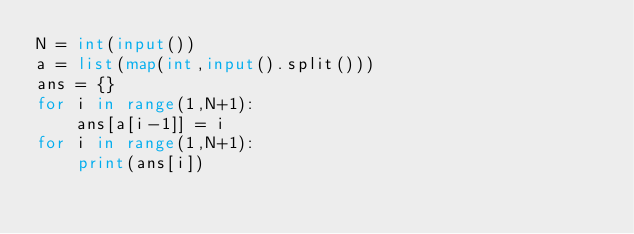Convert code to text. <code><loc_0><loc_0><loc_500><loc_500><_Python_>N = int(input())
a = list(map(int,input().split()))
ans = {}
for i in range(1,N+1):
    ans[a[i-1]] = i 
for i in range(1,N+1):
    print(ans[i])
    </code> 